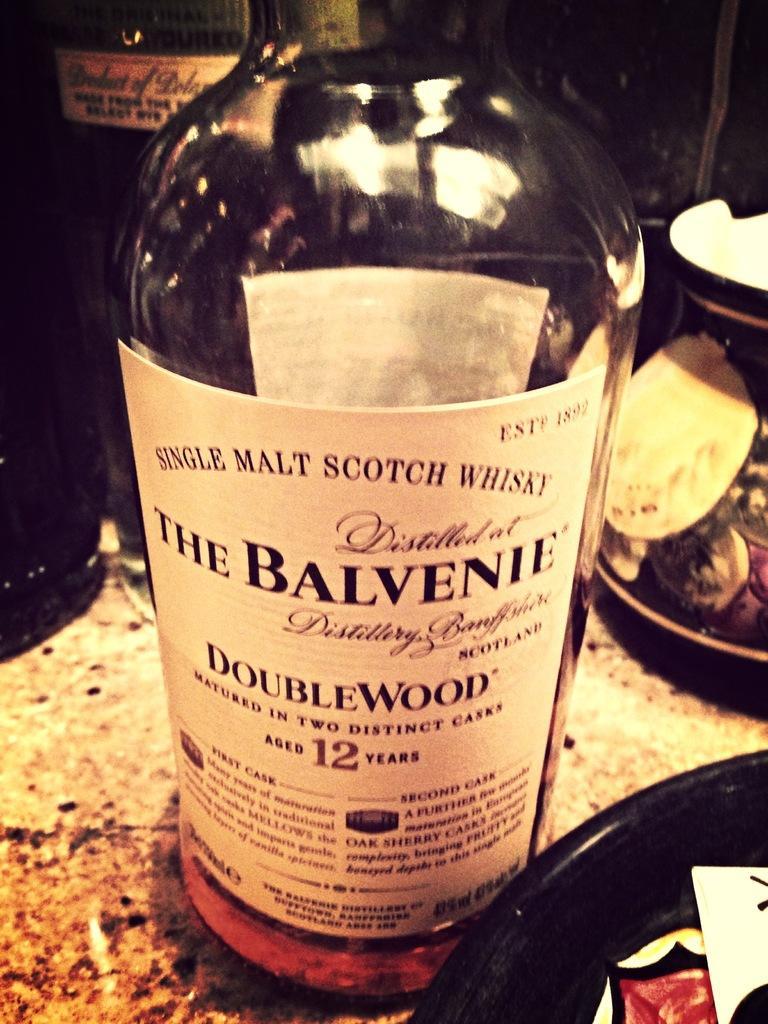Describe this image in one or two sentences. In this picture we can see a bottle. 